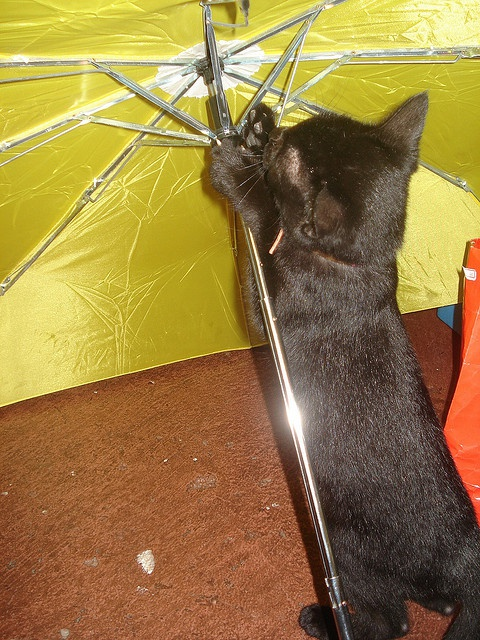Describe the objects in this image and their specific colors. I can see umbrella in gold, khaki, and olive tones and cat in gold, black, gray, and maroon tones in this image. 